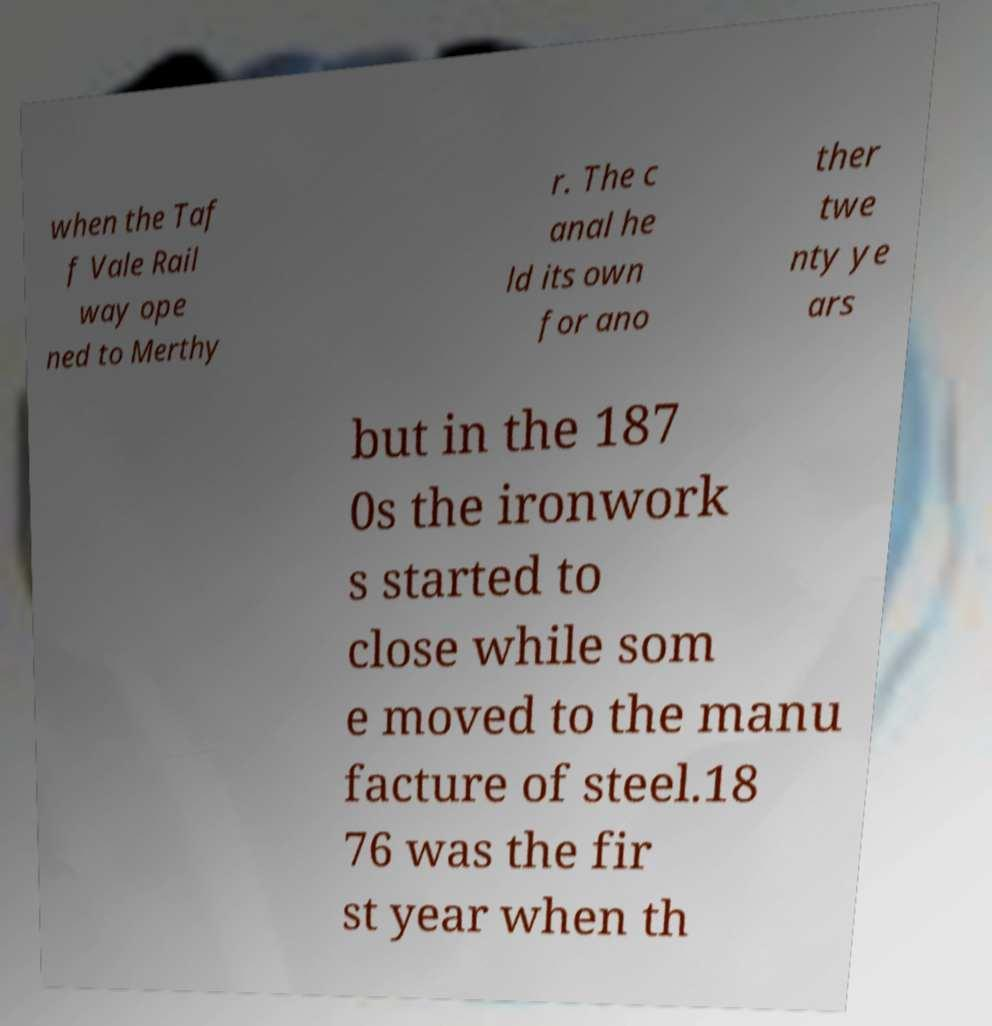Could you assist in decoding the text presented in this image and type it out clearly? when the Taf f Vale Rail way ope ned to Merthy r. The c anal he ld its own for ano ther twe nty ye ars but in the 187 0s the ironwork s started to close while som e moved to the manu facture of steel.18 76 was the fir st year when th 